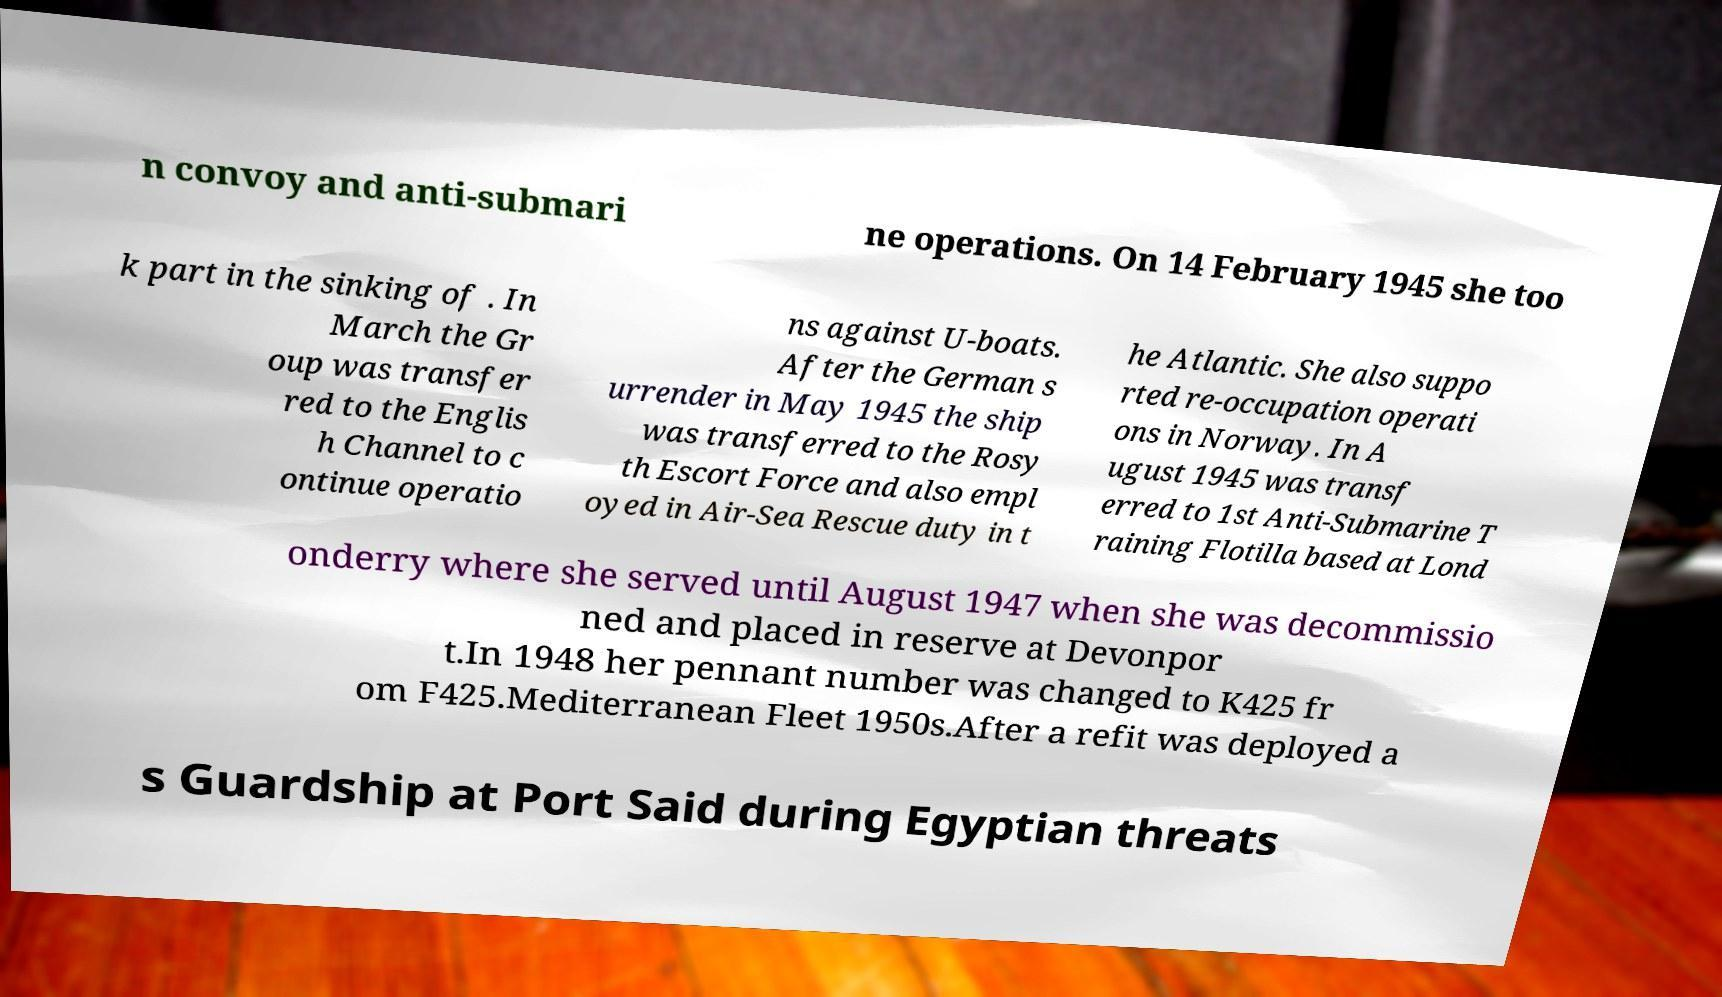There's text embedded in this image that I need extracted. Can you transcribe it verbatim? n convoy and anti-submari ne operations. On 14 February 1945 she too k part in the sinking of . In March the Gr oup was transfer red to the Englis h Channel to c ontinue operatio ns against U-boats. After the German s urrender in May 1945 the ship was transferred to the Rosy th Escort Force and also empl oyed in Air-Sea Rescue duty in t he Atlantic. She also suppo rted re-occupation operati ons in Norway. In A ugust 1945 was transf erred to 1st Anti-Submarine T raining Flotilla based at Lond onderry where she served until August 1947 when she was decommissio ned and placed in reserve at Devonpor t.In 1948 her pennant number was changed to K425 fr om F425.Mediterranean Fleet 1950s.After a refit was deployed a s Guardship at Port Said during Egyptian threats 